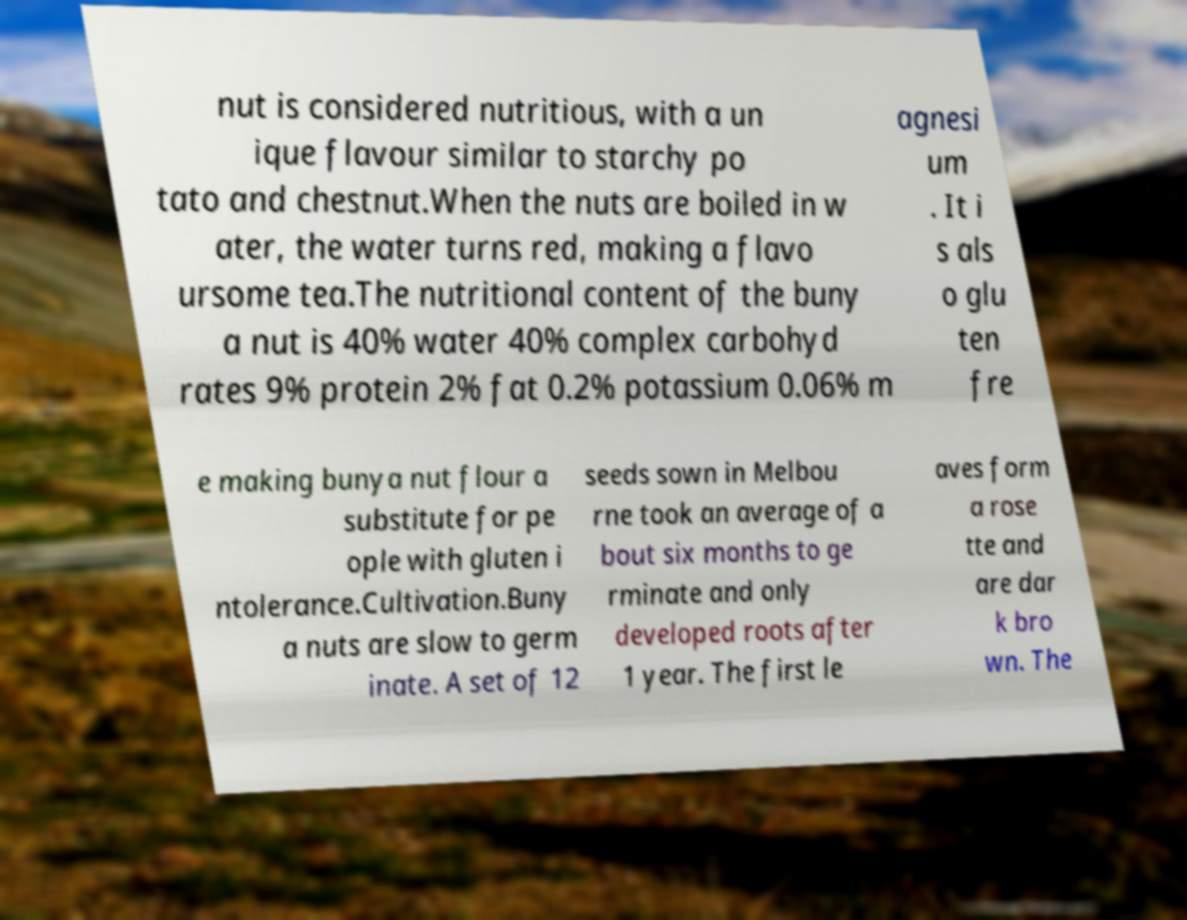Could you extract and type out the text from this image? nut is considered nutritious, with a un ique flavour similar to starchy po tato and chestnut.When the nuts are boiled in w ater, the water turns red, making a flavo ursome tea.The nutritional content of the buny a nut is 40% water 40% complex carbohyd rates 9% protein 2% fat 0.2% potassium 0.06% m agnesi um . It i s als o glu ten fre e making bunya nut flour a substitute for pe ople with gluten i ntolerance.Cultivation.Buny a nuts are slow to germ inate. A set of 12 seeds sown in Melbou rne took an average of a bout six months to ge rminate and only developed roots after 1 year. The first le aves form a rose tte and are dar k bro wn. The 